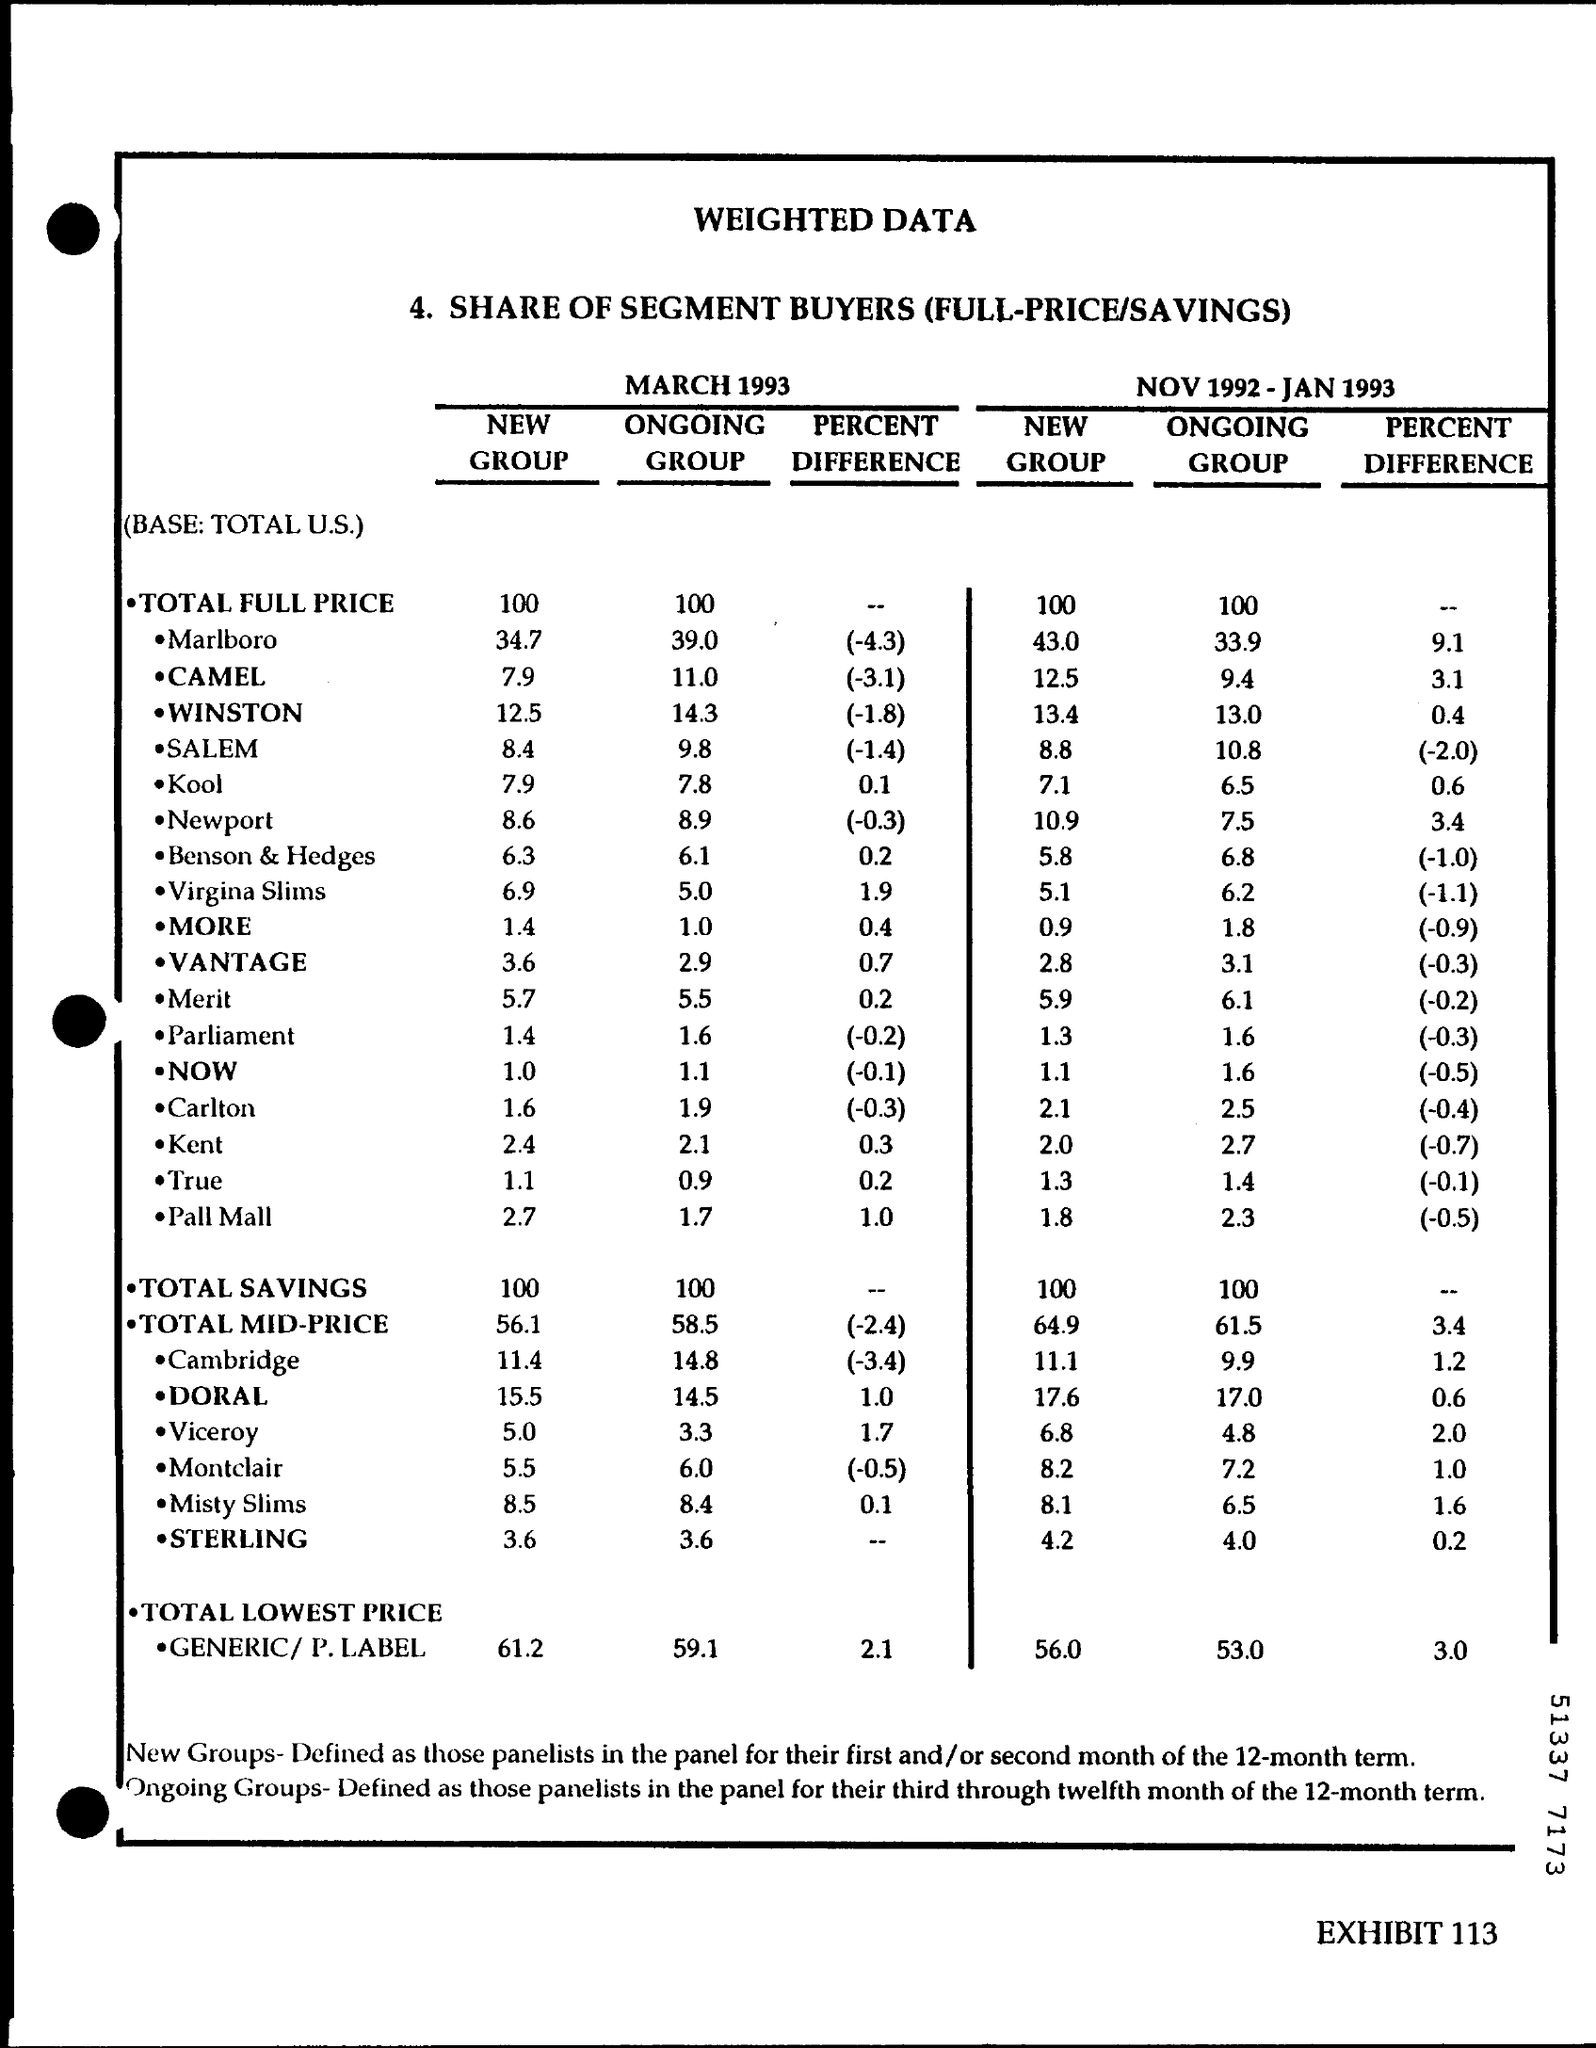Draw attention to some important aspects in this diagram. The letterhead contains the written text 'Weighted data..' 